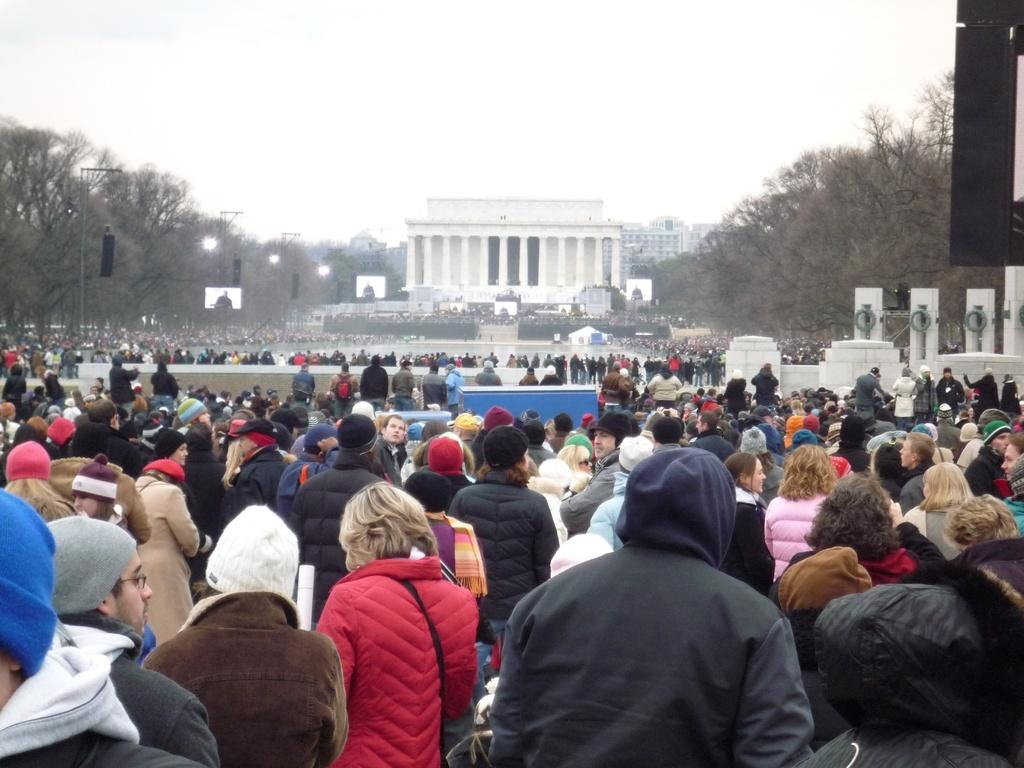How many people are in the image? There is a group of people in the image, but the exact number is not specified. What can be observed about the clothing of the people in the image? The people are wearing different color dresses. What type of structures can be seen in the image? There are buildings in the image. What other natural elements are present in the image? Trees are present in the image. What type of man-made structures are visible in the image? Light poles are visible in the image. What objects are present that might be used for displaying information or advertisements? Boards are present in the image. What type of artistic features can be seen in the image? White color statues are in the image. What is the color of the sky in the image? The sky appears to be white in color. What type of plantation can be seen in the image? There is no plantation present in the image. What part of the body is visible on the statues in the image? The statues are white in color, but no specific body parts are mentioned in the facts provided. 